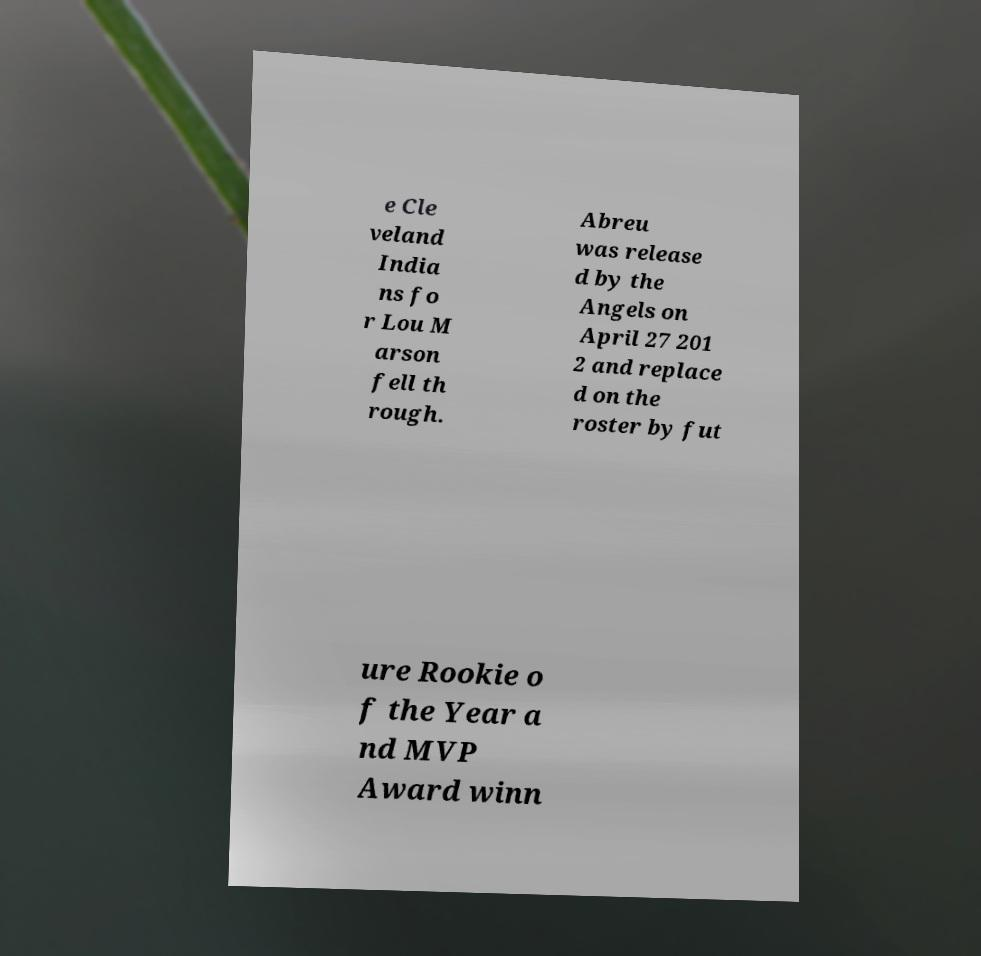For documentation purposes, I need the text within this image transcribed. Could you provide that? e Cle veland India ns fo r Lou M arson fell th rough. Abreu was release d by the Angels on April 27 201 2 and replace d on the roster by fut ure Rookie o f the Year a nd MVP Award winn 